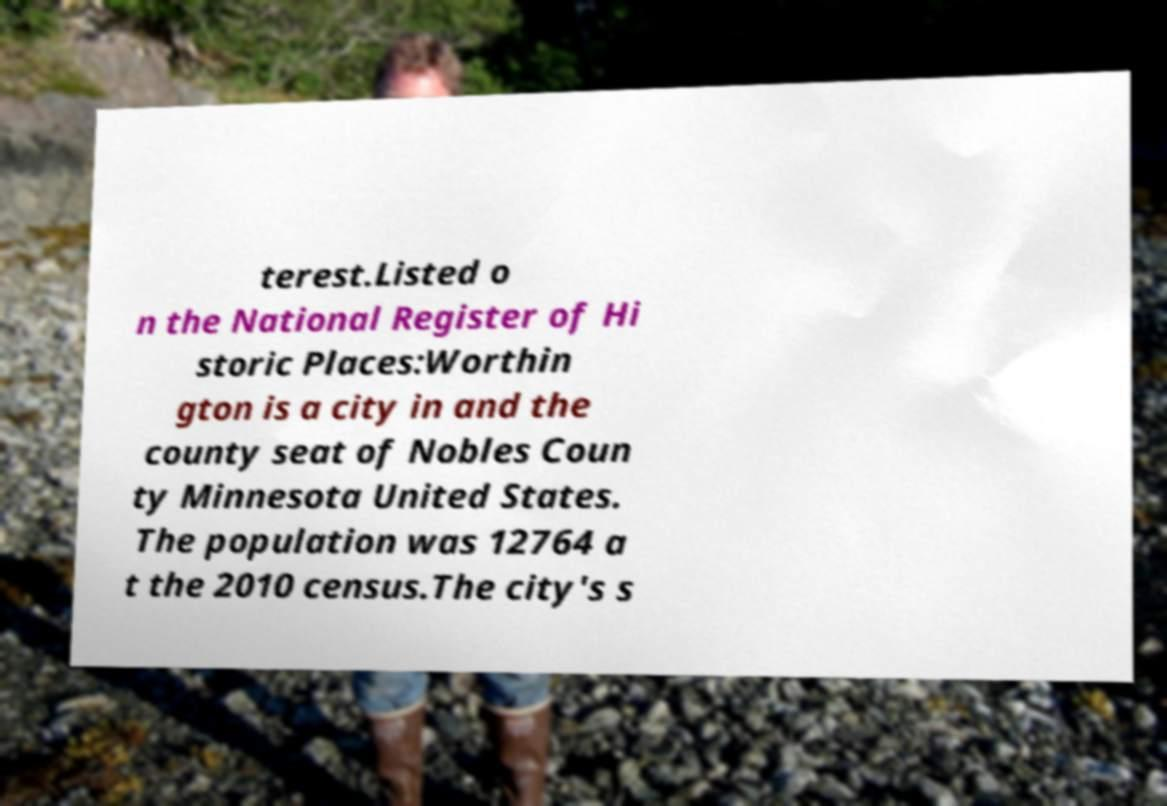I need the written content from this picture converted into text. Can you do that? terest.Listed o n the National Register of Hi storic Places:Worthin gton is a city in and the county seat of Nobles Coun ty Minnesota United States. The population was 12764 a t the 2010 census.The city's s 